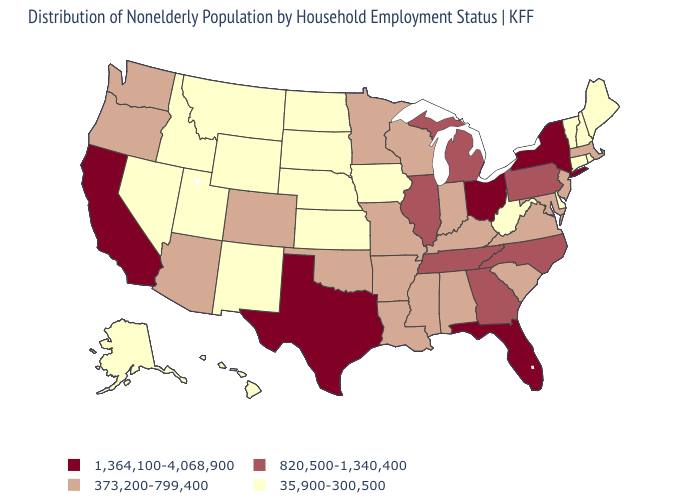Does West Virginia have the highest value in the USA?
Be succinct. No. Name the states that have a value in the range 35,900-300,500?
Be succinct. Alaska, Connecticut, Delaware, Hawaii, Idaho, Iowa, Kansas, Maine, Montana, Nebraska, Nevada, New Hampshire, New Mexico, North Dakota, Rhode Island, South Dakota, Utah, Vermont, West Virginia, Wyoming. What is the value of Kansas?
Write a very short answer. 35,900-300,500. What is the value of California?
Be succinct. 1,364,100-4,068,900. Does Texas have the highest value in the USA?
Keep it brief. Yes. What is the value of Illinois?
Short answer required. 820,500-1,340,400. Does Massachusetts have a higher value than Ohio?
Keep it brief. No. What is the highest value in states that border Nebraska?
Answer briefly. 373,200-799,400. What is the value of Connecticut?
Be succinct. 35,900-300,500. What is the value of Connecticut?
Quick response, please. 35,900-300,500. Name the states that have a value in the range 820,500-1,340,400?
Be succinct. Georgia, Illinois, Michigan, North Carolina, Pennsylvania, Tennessee. Among the states that border Washington , does Idaho have the highest value?
Quick response, please. No. What is the value of Missouri?
Keep it brief. 373,200-799,400. What is the value of Kentucky?
Be succinct. 373,200-799,400. What is the highest value in the USA?
Quick response, please. 1,364,100-4,068,900. 